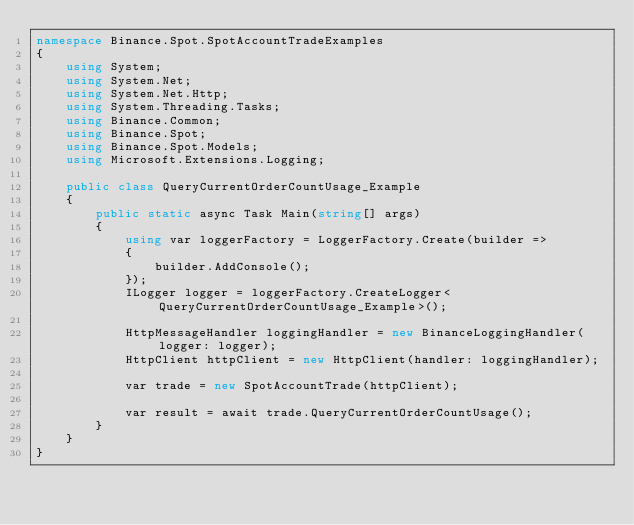Convert code to text. <code><loc_0><loc_0><loc_500><loc_500><_C#_>namespace Binance.Spot.SpotAccountTradeExamples
{
    using System;
    using System.Net;
    using System.Net.Http;
    using System.Threading.Tasks;
    using Binance.Common;
    using Binance.Spot;
    using Binance.Spot.Models;
    using Microsoft.Extensions.Logging;

    public class QueryCurrentOrderCountUsage_Example
    {
        public static async Task Main(string[] args)
        {
            using var loggerFactory = LoggerFactory.Create(builder =>
            {
                builder.AddConsole();
            });
            ILogger logger = loggerFactory.CreateLogger<QueryCurrentOrderCountUsage_Example>();

            HttpMessageHandler loggingHandler = new BinanceLoggingHandler(logger: logger);
            HttpClient httpClient = new HttpClient(handler: loggingHandler);

            var trade = new SpotAccountTrade(httpClient);

            var result = await trade.QueryCurrentOrderCountUsage();
        }
    }
}</code> 